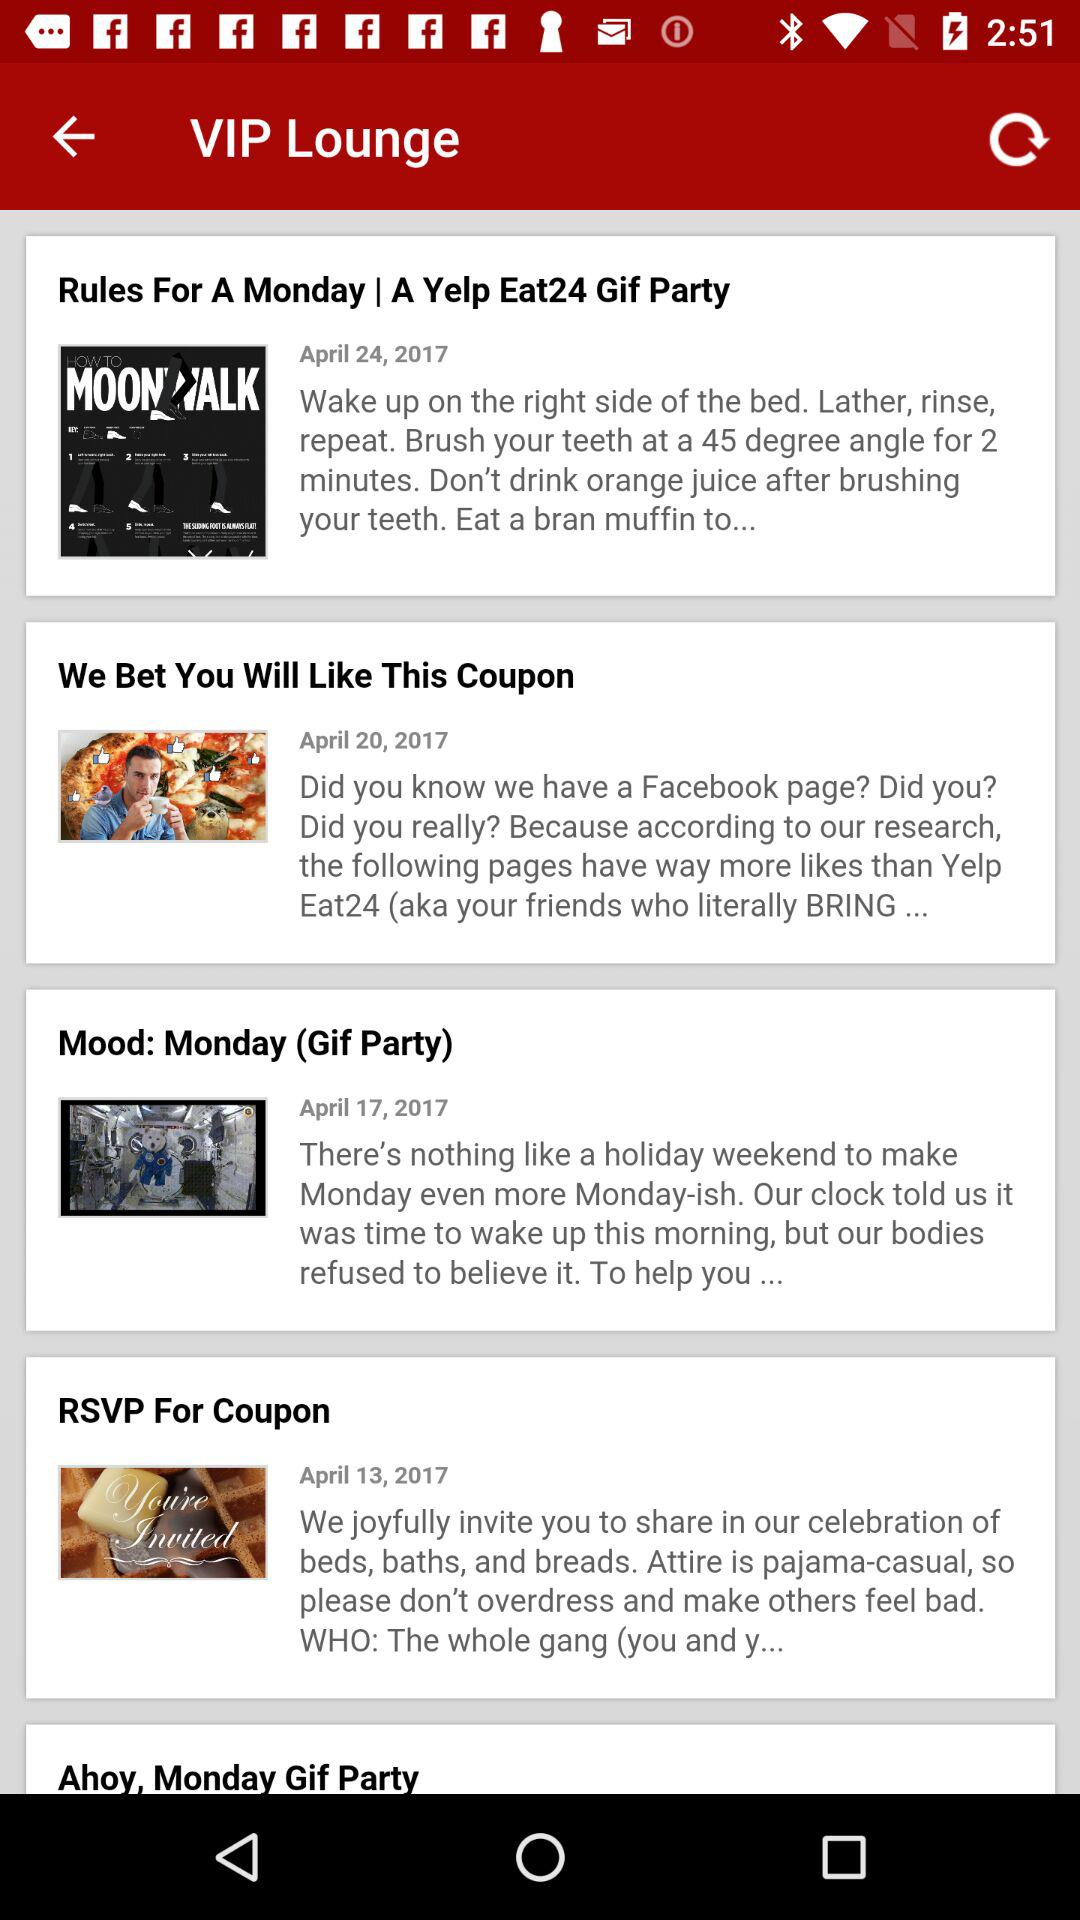On April 20, 2017, which article was published? The article was "We bet You Will Like This Coupon". 